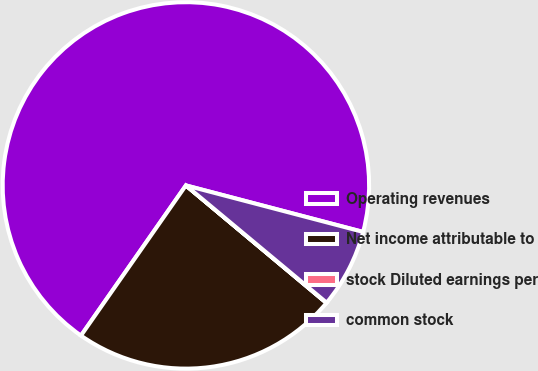<chart> <loc_0><loc_0><loc_500><loc_500><pie_chart><fcel>Operating revenues<fcel>Net income attributable to<fcel>stock Diluted earnings per<fcel>common stock<nl><fcel>69.38%<fcel>23.62%<fcel>0.03%<fcel>6.97%<nl></chart> 